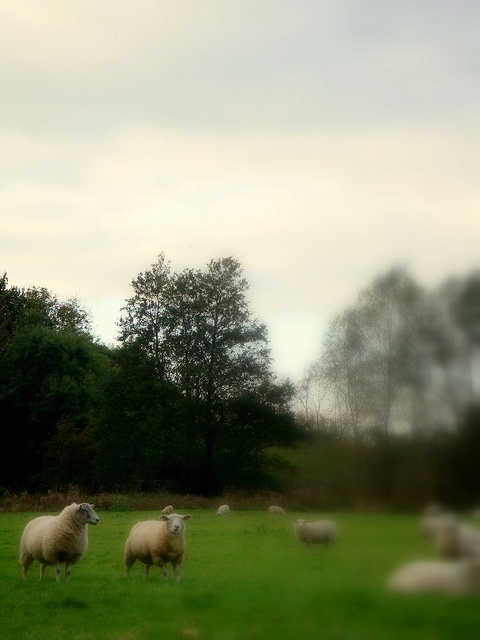Describe the objects in this image and their specific colors. I can see sheep in beige, black, darkgreen, tan, and gray tones, sheep in beige, darkgreen, black, tan, and olive tones, sheep in beige, gray, darkgreen, and olive tones, sheep in beige, darkgreen, gray, and black tones, and sheep in beige, darkgreen, and olive tones in this image. 